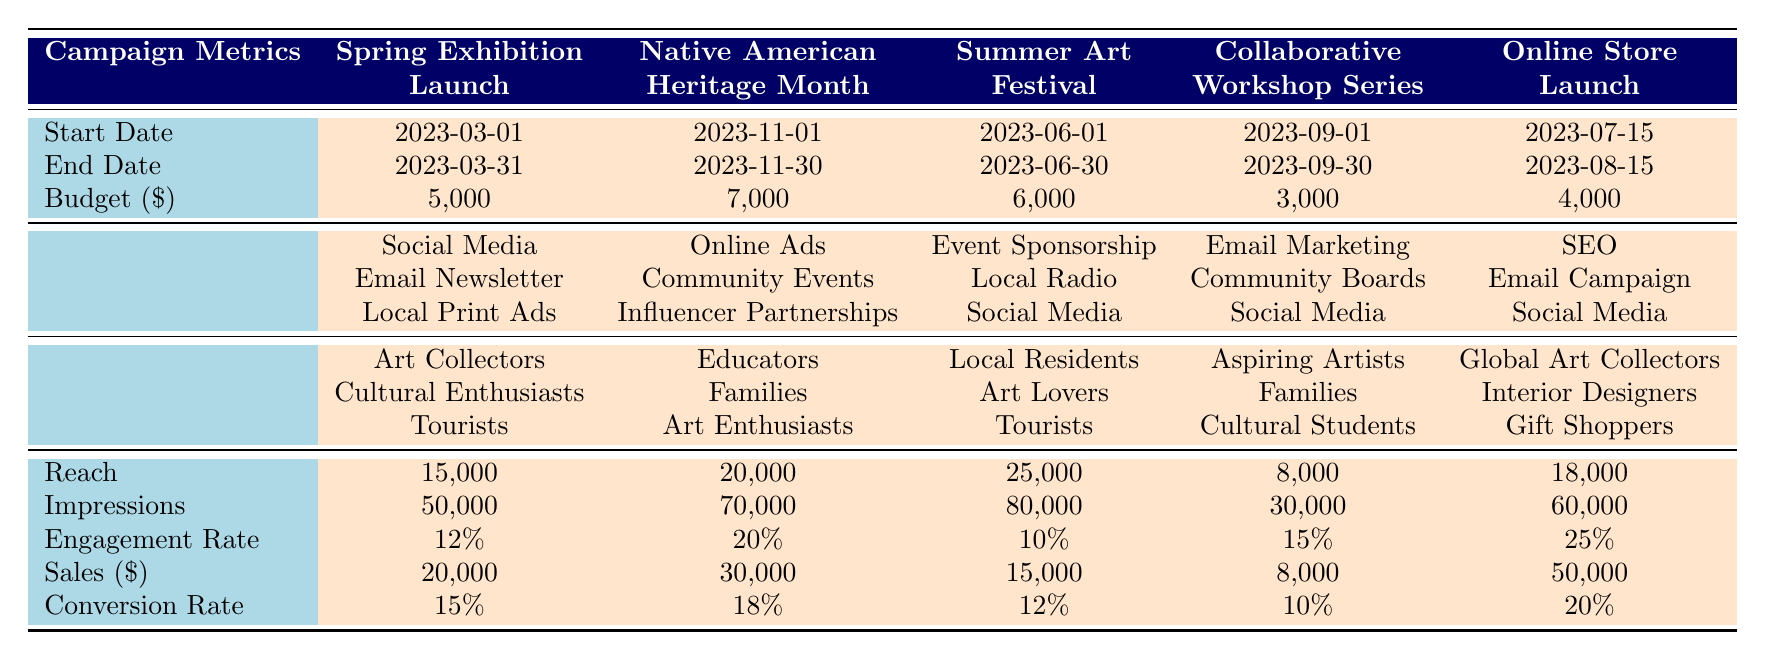What is the budget for the "Native American Heritage Month" campaign? The table lists the budget for each campaign. For the "Native American Heritage Month" campaign, the budget is specifically mentioned as 7,000.
Answer: 7,000 Which campaign had the highest reach? The reach for each campaign is provided in the table. By comparing the values, "Summer Art Festival Participation" at 25,000 has the highest reach among all campaigns.
Answer: 25,000 What was the engagement rate for the "Online Store Launch" campaign? The engagement rate for each campaign is listed separately. For the "Online Store Launch," the engagement rate is provided as 25%.
Answer: 25% How much total sales were generated from all campaigns combined? To find the total sales, we sum the sales figures from each campaign: 20,000 + 30,000 + 15,000 + 8,000 + 50,000 = 123,000.
Answer: 123,000 Did the "Collaborative Workshop Series" campaign reach more than 10,000 people? The reach for the "Collaborative Workshop Series" is 8,000, which is less than 10,000, making the statement false.
Answer: No Which campaign had the lowest conversion rate? By comparing the conversion rates for all campaigns, we find "Collaborative Workshop Series" has the lowest rate at 10%.
Answer: 10% What is the average sales amount of all campaigns? The total sales are 123,000, and there are 5 campaigns, so the average sales amount is 123,000 / 5 = 24,600.
Answer: 24,600 Is the engagement rate for the "Spring Exhibition Launch" campaign higher than that of the "Summer Art Festival Participation"? The engagement rate for "Spring Exhibition Launch" is 12% while for "Summer Art Festival Participation" it is 10%. Since 12% is greater than 10%, this is true.
Answer: Yes What is the difference in budget between the "Summer Art Festival Participation" and "Collaborative Workshop Series"? The budget for "Summer Art Festival Participation" is 6,000 and for "Collaborative Workshop Series" is 3,000. The difference is 6,000 - 3,000 = 3,000.
Answer: 3,000 What was the target audience focus for the "Online Store Launch"? The table specifies the target audience for each campaign. The target audience for "Online Store Launch" includes Global Art Collectors, Interior Designers, and Gift Shoppers.
Answer: Global Art Collectors, Interior Designers, Gift Shoppers 